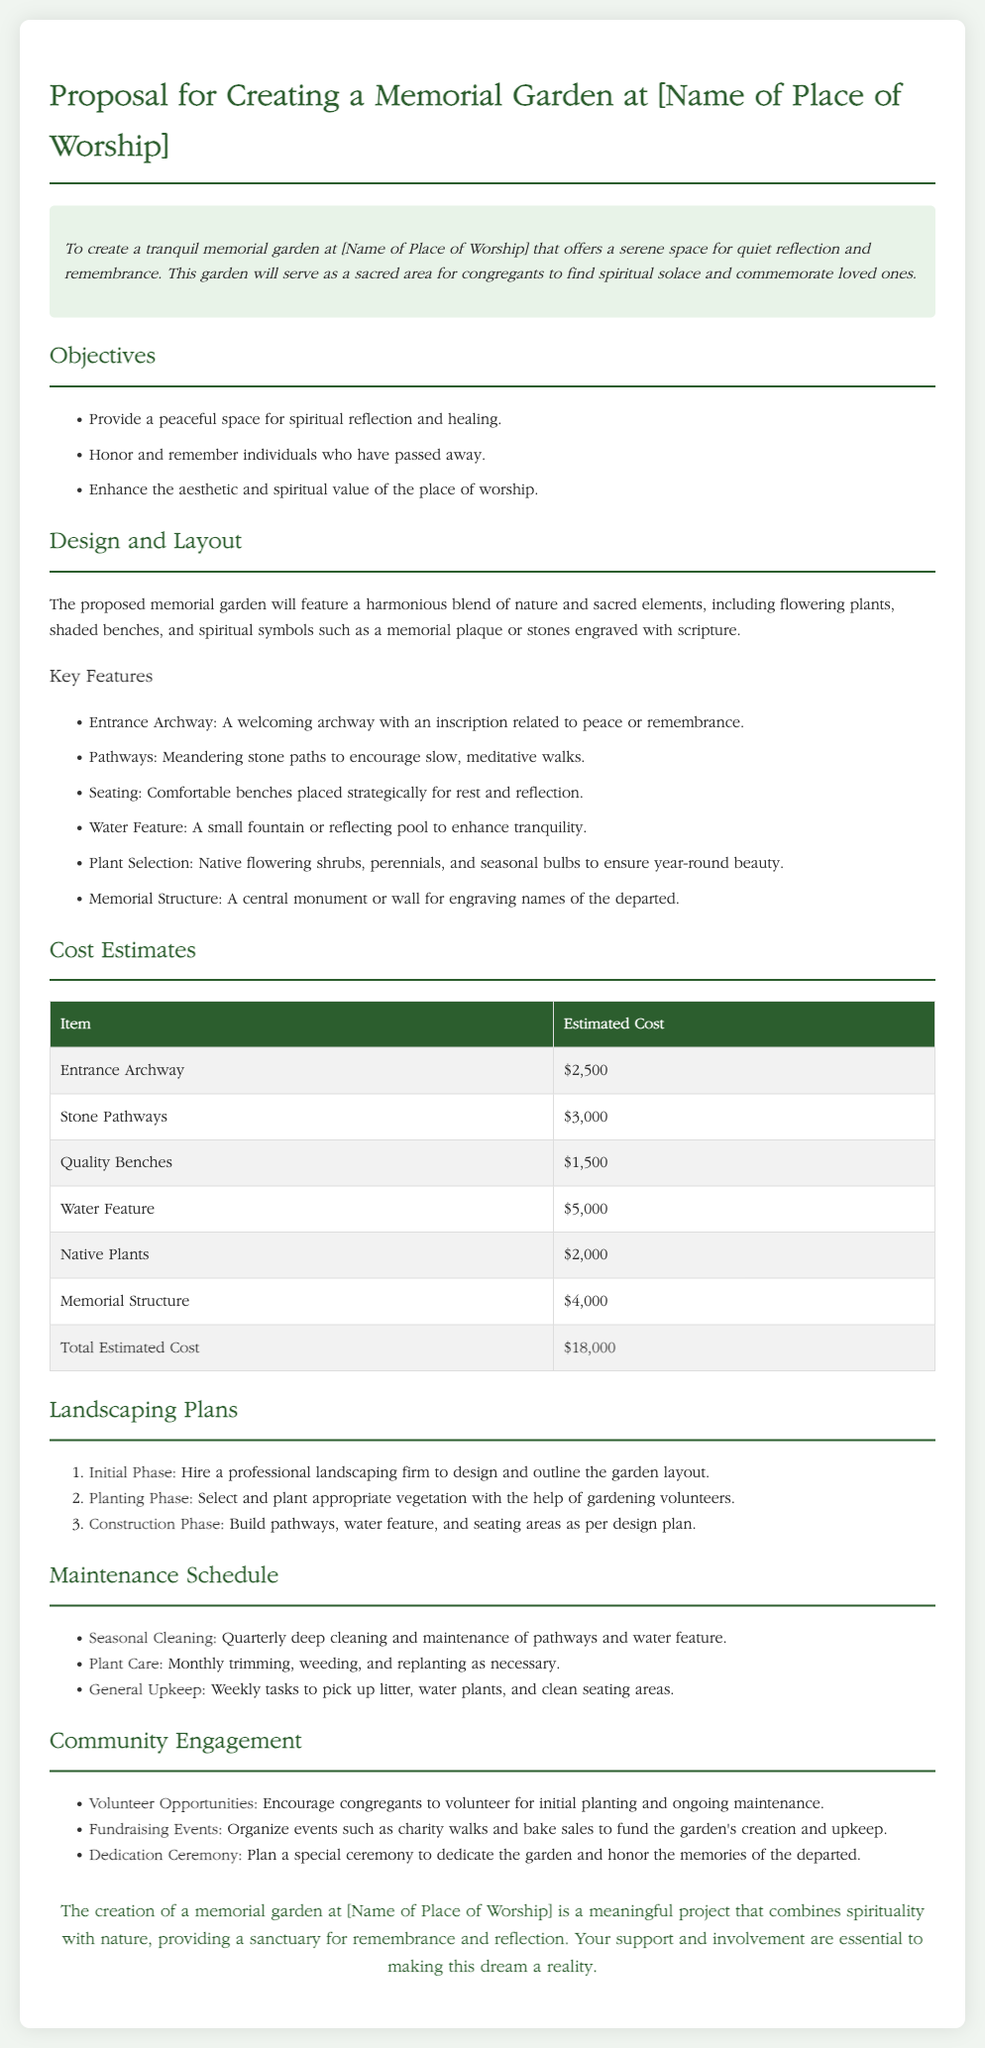What is the purpose of the memorial garden? The proposal states that the purpose is to offer a serene space for quiet reflection and remembrance.
Answer: serene space for quiet reflection and remembrance What is the total estimated cost? The total estimated cost is provided at the end of the cost estimates section.
Answer: $18,000 How many key features are listed in the proposal? The proposal enumerates the key features of the garden in a list format.
Answer: six What type of plants will be included in the garden? The document mentions specific types of plants that will be selected for the garden.
Answer: Native flowering shrubs, perennials, and seasonal bulbs What is one of the community engagement strategies mentioned? The proposal outlines several strategies to engage the community, focusing on involvement and support.
Answer: Volunteer Opportunities What is the initial phase of the landscaping plan? The proposal details the steps of the landscaping plan and the initial phase specifically.
Answer: Hire a professional landscaping firm How often will the seasonal cleaning occur? The maintenance schedule indicates the frequency of cleaning operations for the garden.
Answer: Quarterly What type of ceremony is planned for the garden? The document describes a specific event to commemorate the garden's opening.
Answer: Dedication Ceremony 